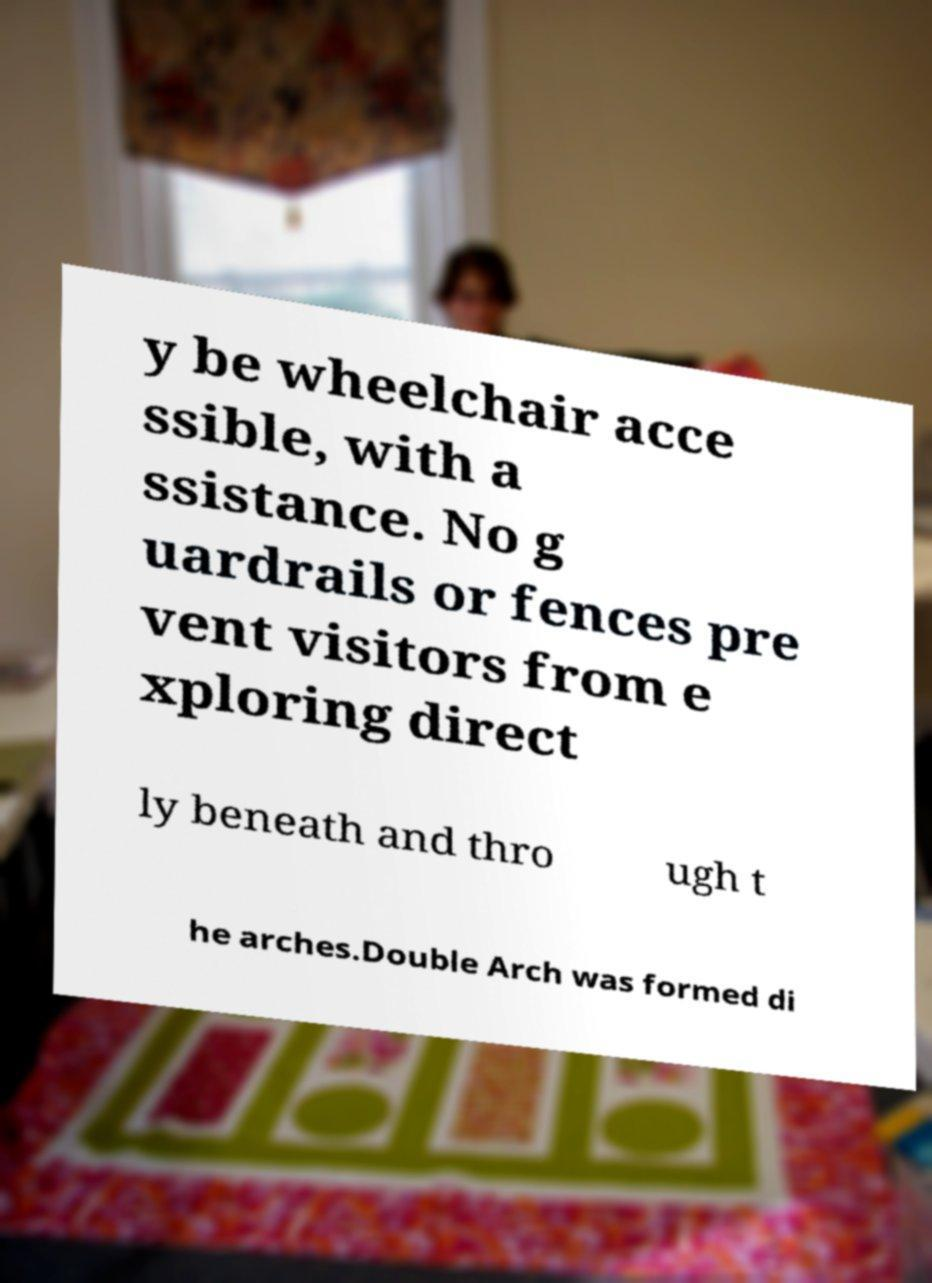For documentation purposes, I need the text within this image transcribed. Could you provide that? y be wheelchair acce ssible, with a ssistance. No g uardrails or fences pre vent visitors from e xploring direct ly beneath and thro ugh t he arches.Double Arch was formed di 